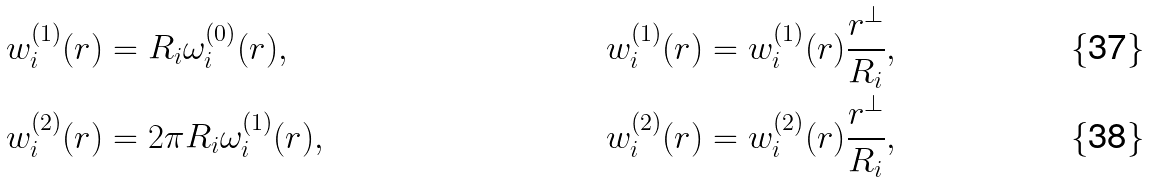<formula> <loc_0><loc_0><loc_500><loc_500>w _ { i } ^ { ( 1 ) } ( { r } ) & = R _ { i } \omega ^ { ( 0 ) } _ { i } ( { r } ) , \quad & { w } _ { i } ^ { ( 1 ) } ( { r } ) & = w _ { i } ^ { ( 1 ) } ( { r } ) \frac { { r } ^ { \perp } } { R _ { i } } , \\ w _ { i } ^ { ( 2 ) } ( { r } ) & = 2 \pi R _ { i } \omega ^ { ( 1 ) } _ { i } ( { r } ) , \quad & { w } _ { i } ^ { ( 2 ) } ( { r } ) & = w _ { i } ^ { ( 2 ) } ( { r } ) \frac { { r } ^ { \perp } } { R _ { i } } ,</formula> 